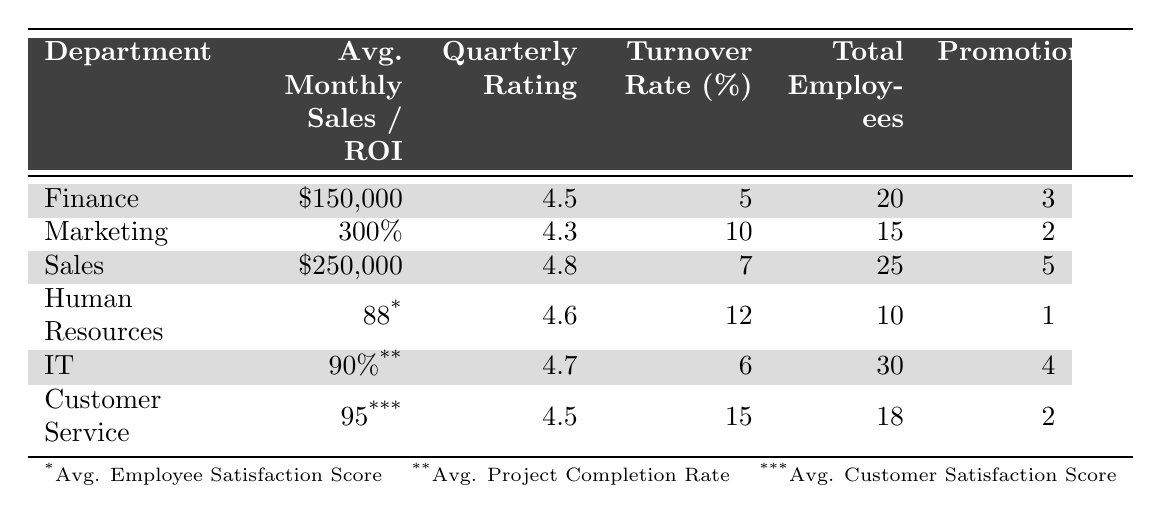What is the Average Monthly Sales in the Sales department? The table specifies that the Average Monthly Sales for the Sales department is listed as $250,000.
Answer: $250,000 What is the Quarterly Performance Rating for the IT department? According to the table, the Quarterly Performance Rating for the IT department is 4.7.
Answer: 4.7 Which department has the highest Employee Turnover Rate? The Employee Turnover Rate for each department is listed, and the highest rate is 15% for the Customer Service department.
Answer: Customer Service How many Total Employees are there in the Finance department? The table indicates that there are 20 Total Employees in the Finance department.
Answer: 20 What is the promotion-to-employee ratio for the Marketing department? The Marketing department has 2 Promotions granted and 15 Total Employees, so the ratio is calculated as 2/15 = 0.1333.
Answer: 0.1333 Which department has the highest Quarterly Performance Rating? By comparing the Quarterly Performance Ratings, the Sales department has the highest rating at 4.8.
Answer: Sales What is the average Employee Turnover Rate across all departments? The Employee Turnover Rates are 5%, 10%, 7%, 12%, 6%, and 15%. Summing these gives 55%, and dividing by 6 (the number of departments) gives 55/6 = 9.17%.
Answer: 9.17% Do more Promotions correlate with a lower Employee Turnover Rate across departments? Comparing Promotions and Turnover Rates: Sales (5 promotions, 7% turnover), Finance (3 promotions, 5% turnover), IT (4 promotions, 6% turnover), HR (1 promotion, 12% turnover), Marketing (2 promotions, 10% turnover), Customer Service (2 promotions, 15% turnover). The data shows no clear correlation but suggests that more promotions might relate to lower turnover in some cases, especially in Sales and Finance.
Answer: No clear correlation What is the total number of Promotions granted across all departments? The Promotions granted in each department are summed up: 3 (Finance) + 2 (Marketing) + 5 (Sales) + 1 (HR) + 4 (IT) + 2 (Customer Service) = 17.
Answer: 17 Which department has the highest Average Customer Satisfaction Score? The table shows that the Customer Service department has an Average Customer Satisfaction Score of 95, which is the highest among all departments.
Answer: Customer Service 